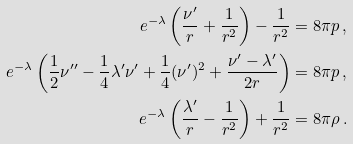<formula> <loc_0><loc_0><loc_500><loc_500>e ^ { - \lambda } \left ( \frac { \nu ^ { \prime } } { r } + \frac { 1 } { r ^ { 2 } } \right ) - \frac { 1 } { r ^ { 2 } } & = 8 \pi p \, , \\ e ^ { - \lambda } \left ( \frac { 1 } { 2 } \nu ^ { \prime \prime } - \frac { 1 } { 4 } \lambda ^ { \prime } \nu ^ { \prime } + \frac { 1 } { 4 } ( \nu ^ { \prime } ) ^ { 2 } + \frac { \nu ^ { \prime } - \lambda ^ { \prime } } { 2 r } \right ) & = 8 \pi p \, , \\ e ^ { - \lambda } \left ( \frac { \lambda ^ { \prime } } { r } - \frac { 1 } { r ^ { 2 } } \right ) + \frac { 1 } { r ^ { 2 } } & = 8 \pi \rho \, .</formula> 